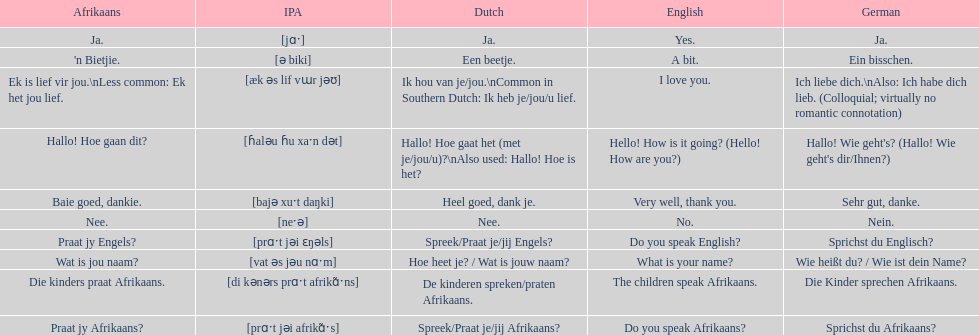How do you say 'yes' in afrikaans? Ja. 